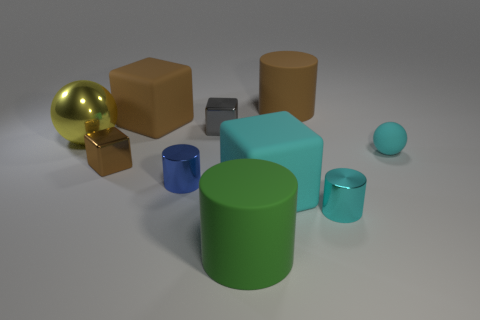What is the material of the small cylinder that is the same color as the rubber ball?
Your answer should be very brief. Metal. Are there fewer spheres that are right of the tiny brown thing than tiny cyan matte objects left of the cyan shiny cylinder?
Provide a succinct answer. No. There is a rubber cylinder that is behind the large yellow object; is its color the same as the tiny cylinder to the right of the tiny gray metal object?
Offer a very short reply. No. Are there any brown objects made of the same material as the small cyan ball?
Offer a very short reply. Yes. How big is the thing in front of the tiny cylinder that is on the right side of the cyan rubber cube?
Offer a terse response. Large. Are there more big brown cubes than big blocks?
Provide a succinct answer. No. Do the cyan cylinder that is right of the gray object and the big brown cube have the same size?
Your answer should be very brief. No. How many cubes have the same color as the small matte thing?
Give a very brief answer. 1. Is the shape of the large yellow metallic object the same as the tiny brown metal object?
Your answer should be very brief. No. What size is the cyan object that is the same shape as the big green rubber object?
Your answer should be very brief. Small. 